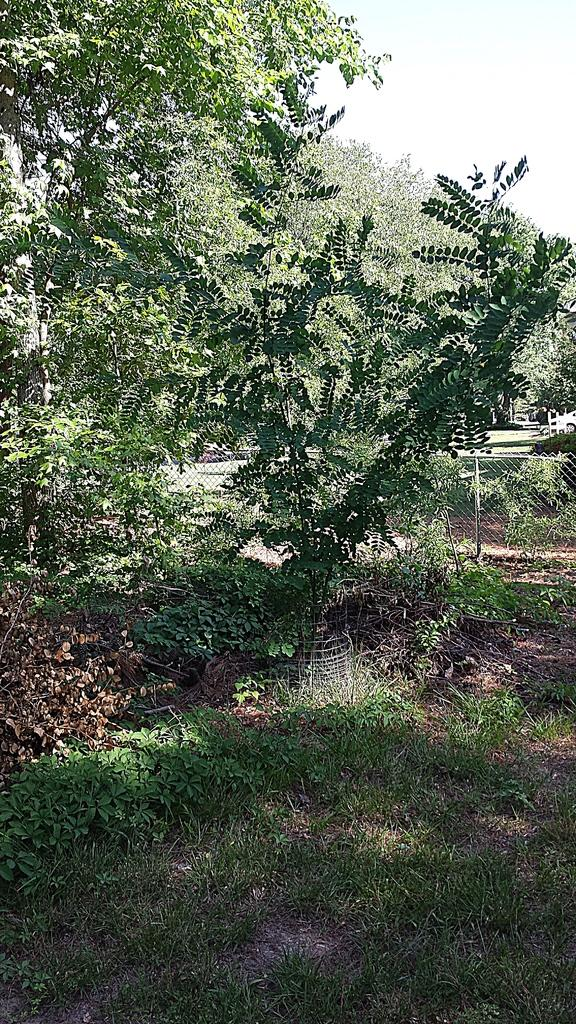What type of vegetation is present at the bottom of the image? There is grass on the ground at the bottom of the image. What can be seen in the background of the image? There are many trees and a fencing of mesh in the background of the image. What type of stitch is used to create the fencing in the image? The image does not show any stitching or fabric; it is a mesh fencing. What type of government is depicted in the image? There is no depiction of a government in the image; it features grass, trees, and a mesh fencing. 